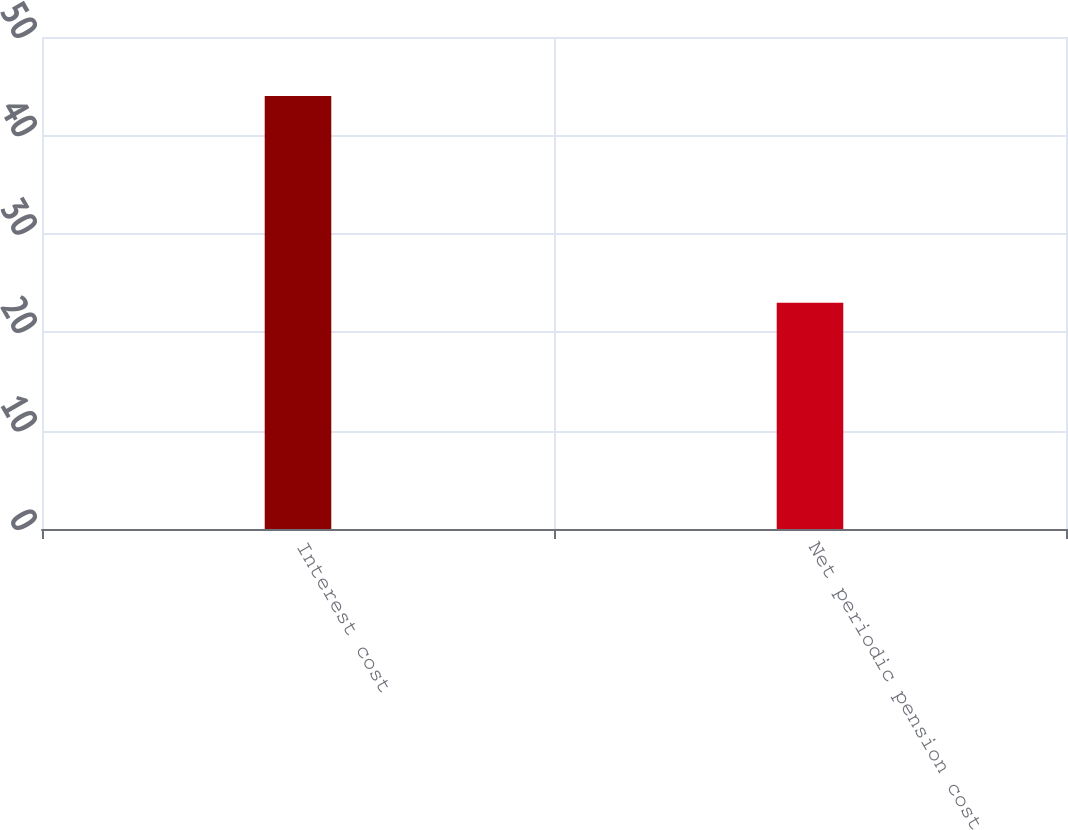<chart> <loc_0><loc_0><loc_500><loc_500><bar_chart><fcel>Interest cost<fcel>Net periodic pension cost<nl><fcel>44<fcel>23<nl></chart> 